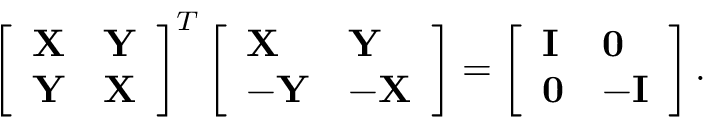Convert formula to latex. <formula><loc_0><loc_0><loc_500><loc_500>\left [ \begin{array} { l l } { X } & { Y } \\ { Y } & { X } \end{array} \right ] ^ { T } \left [ \begin{array} { l l } { X } & { Y } \\ { - Y } & { - X } \end{array} \right ] = \left [ \begin{array} { l l } { I } & { 0 } \\ { 0 } & { - I } \end{array} \right ] .</formula> 